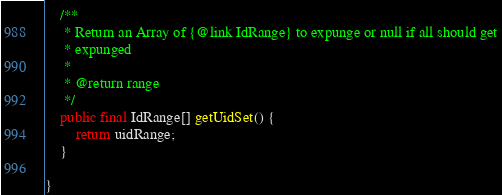Convert code to text. <code><loc_0><loc_0><loc_500><loc_500><_Java_>    /**
     * Return an Array of {@link IdRange} to expunge or null if all should get
     * expunged
     * 
     * @return range
     */
    public final IdRange[] getUidSet() {
        return uidRange;
    }

}
</code> 